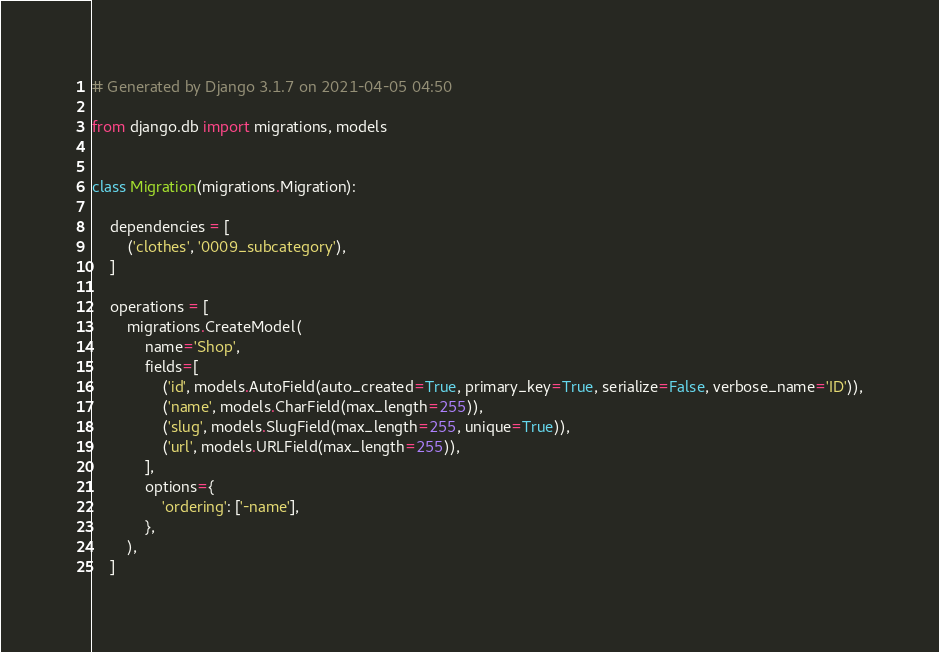<code> <loc_0><loc_0><loc_500><loc_500><_Python_># Generated by Django 3.1.7 on 2021-04-05 04:50

from django.db import migrations, models


class Migration(migrations.Migration):

    dependencies = [
        ('clothes', '0009_subcategory'),
    ]

    operations = [
        migrations.CreateModel(
            name='Shop',
            fields=[
                ('id', models.AutoField(auto_created=True, primary_key=True, serialize=False, verbose_name='ID')),
                ('name', models.CharField(max_length=255)),
                ('slug', models.SlugField(max_length=255, unique=True)),
                ('url', models.URLField(max_length=255)),
            ],
            options={
                'ordering': ['-name'],
            },
        ),
    ]
</code> 